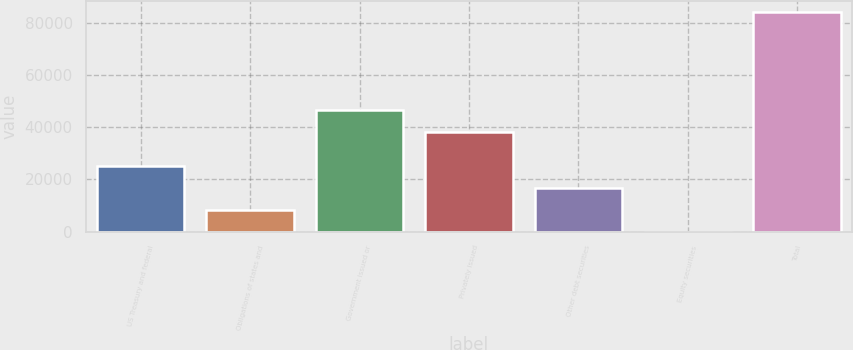<chart> <loc_0><loc_0><loc_500><loc_500><bar_chart><fcel>US Treasury and federal<fcel>Obligations of states and<fcel>Government issued or<fcel>Privately issued<fcel>Other debt securities<fcel>Equity securities<fcel>Total<nl><fcel>25268.8<fcel>8425.6<fcel>46705.6<fcel>38284<fcel>16847.2<fcel>4<fcel>84220<nl></chart> 